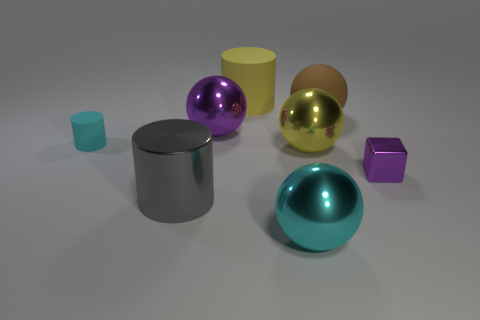Subtract all yellow metal balls. How many balls are left? 3 Add 2 big gray blocks. How many objects exist? 10 Subtract 1 balls. How many balls are left? 3 Subtract all cyan spheres. How many spheres are left? 3 Subtract all red cylinders. Subtract all purple blocks. How many cylinders are left? 3 Subtract all blocks. How many objects are left? 7 Add 1 large red matte objects. How many large red matte objects exist? 1 Subtract 1 purple spheres. How many objects are left? 7 Subtract all cyan rubber objects. Subtract all yellow shiny things. How many objects are left? 6 Add 7 brown spheres. How many brown spheres are left? 8 